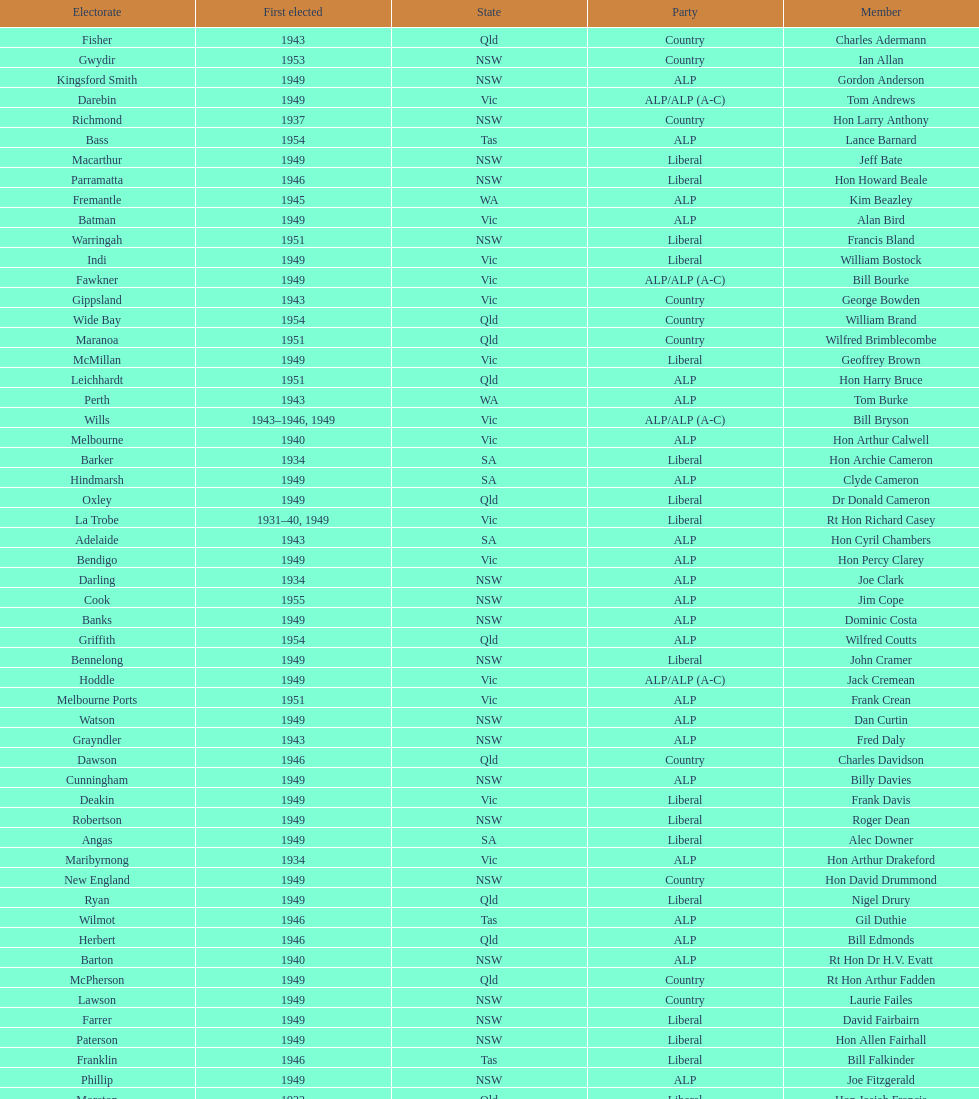What is the number of alp party members elected? 57. 